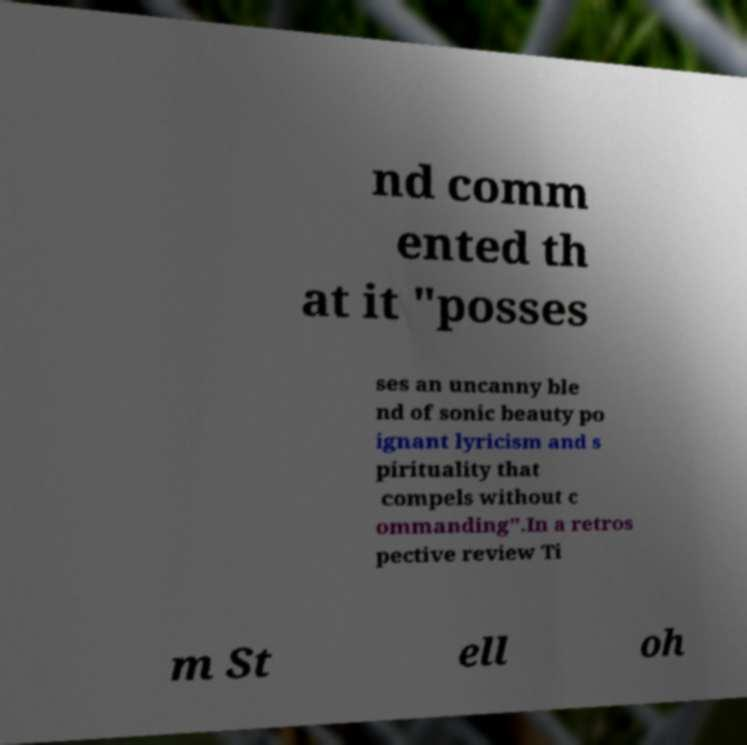Could you assist in decoding the text presented in this image and type it out clearly? nd comm ented th at it "posses ses an uncanny ble nd of sonic beauty po ignant lyricism and s pirituality that compels without c ommanding".In a retros pective review Ti m St ell oh 